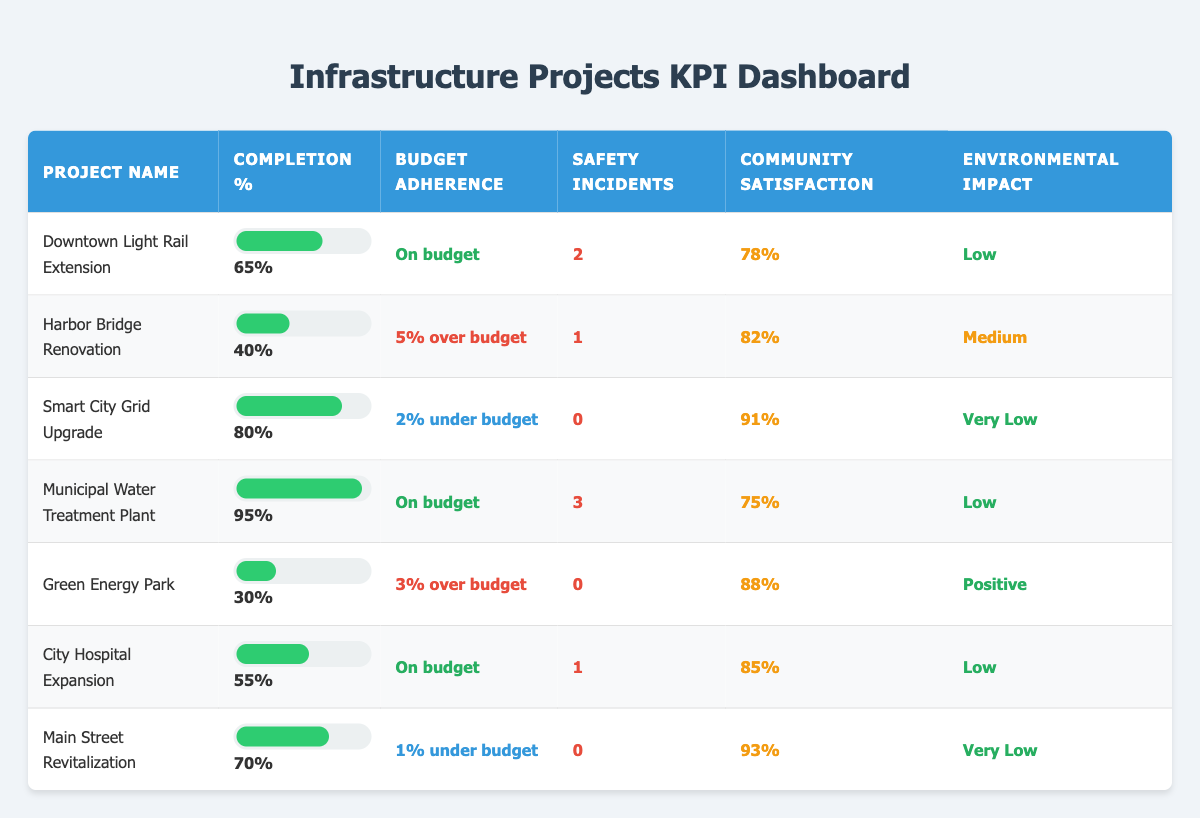What is the completion percentage of the Municipal Water Treatment Plant? The completion percentage for the Municipal Water Treatment Plant is listed directly in the table as 95%.
Answer: 95% How many safety incidents were recorded for the Smart City Grid Upgrade? The Smart City Grid Upgrade has zero safety incidents, which is indicated in the table.
Answer: 0 Which project has the highest community satisfaction score? By comparing the community satisfaction percentages, the Smart City Grid Upgrade has the highest score of 91%, according to the table's values.
Answer: 91% Are there any projects currently under budget? Yes, there are two projects listed as under budget: the Smart City Grid Upgrade at 2% under budget and Main Street Revitalization at 1% under budget.
Answer: Yes What is the average completion percentage of all projects listed in the table? To calculate the average completion percentage, sum the completion percentages: (65 + 40 + 80 + 95 + 30 + 55 + 70) = 435. There are 7 projects total, so the average is 435/7 = 62.14%.
Answer: 62.14% Which project has the most safety incidents? The Municipal Water Treatment Plant has the most safety incidents recorded, with 3 incidents according to the table data, more than any other project.
Answer: Municipal Water Treatment Plant What is the total percentage of community satisfaction for projects with low environmental impact? The projects with low environmental impact are the Downtown Light Rail Extension, Municipal Water Treatment Plant, City Hospital Expansion, and Green Energy Park. Their community satisfaction scores are 78%, 75%, 85%, and 88%, respectively. Summing those gives: (78 + 75 + 85 + 88) = 326. The total community satisfaction score for these projects is 326%.
Answer: 326% Is the Harbor Bridge Renovation on budget? No, the Harbor Bridge Renovation is listed as 5% over budget according to the budget adherence column.
Answer: No Which project has the least community satisfaction, and what is its score? The Municipal Water Treatment Plant has the least community satisfaction at a score of 75%, which is directly available in the table.
Answer: Municipal Water Treatment Plant, 75% 